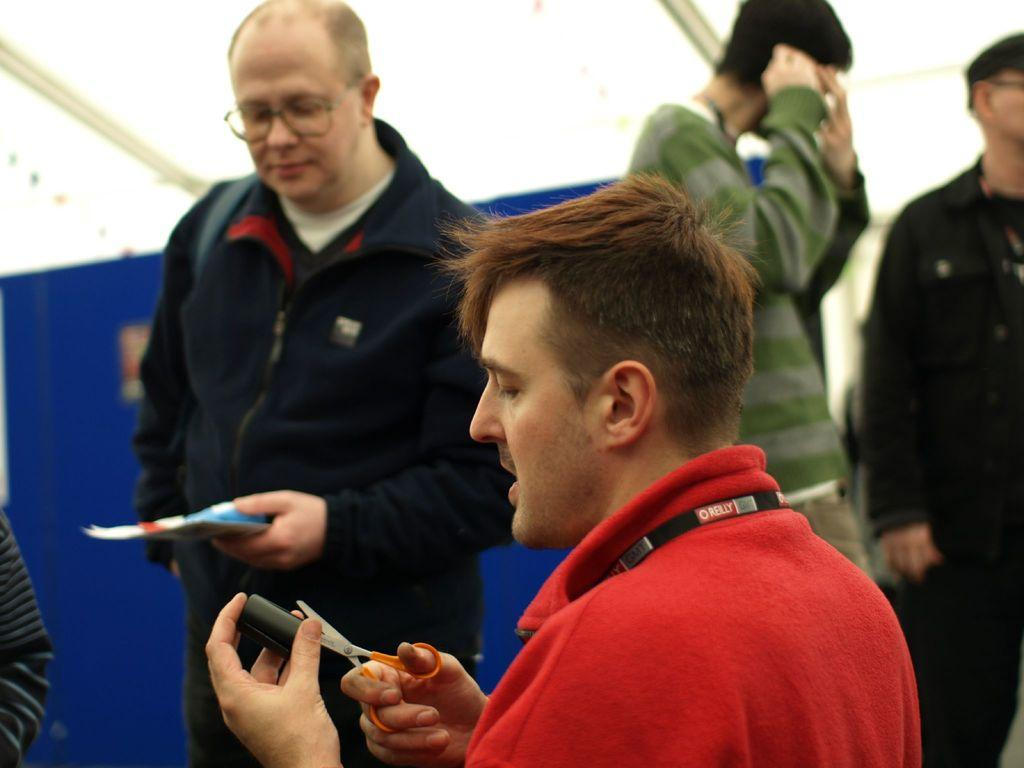How many people are in the image? There are people in the image, but the exact number is not specified. What is the person holding in the image? The person is holding scissors in the image. What is the person wearing while holding the scissors? The person holding scissors is wearing a red dress. What colors can be seen in the background of the image? The background of the image has a blue and white color scheme. What type of hospital can be seen in the image? There is no mention of a hospital in the image. 